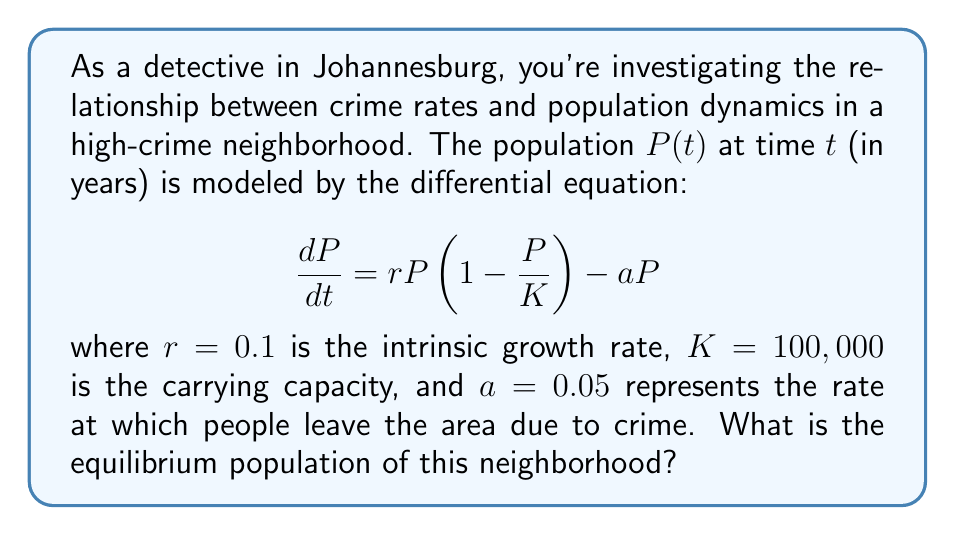What is the answer to this math problem? To find the equilibrium population, we need to set $\frac{dP}{dt} = 0$ and solve for $P$:

1) Set the equation equal to zero:
   $$0 = rP(1 - \frac{P}{K}) - aP$$

2) Substitute the given values:
   $$0 = 0.1P(1 - \frac{P}{100,000}) - 0.05P$$

3) Expand the equation:
   $$0 = 0.1P - \frac{0.1P^2}{100,000} - 0.05P$$

4) Combine like terms:
   $$0 = 0.05P - \frac{0.1P^2}{100,000}$$

5) Multiply all terms by 100,000:
   $$0 = 5,000P - 0.1P^2$$

6) Factor out P:
   $$0 = P(5,000 - 0.1P)$$

7) Solve for P:
   Either $P = 0$ or $5,000 - 0.1P = 0$
   
   For the non-zero solution: $0.1P = 5,000$
   
   $P = 50,000$

Therefore, the equilibrium population is 50,000 people.
Answer: 50,000 people 